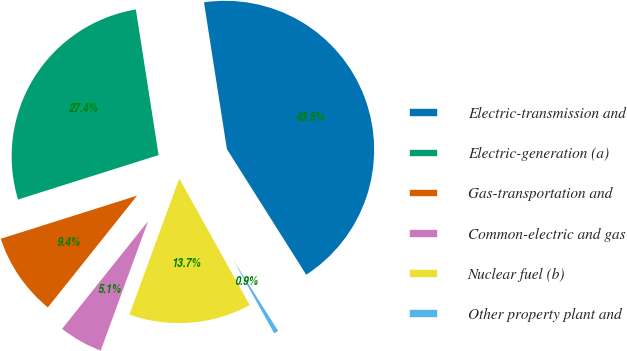<chart> <loc_0><loc_0><loc_500><loc_500><pie_chart><fcel>Electric-transmission and<fcel>Electric-generation (a)<fcel>Gas-transportation and<fcel>Common-electric and gas<fcel>Nuclear fuel (b)<fcel>Other property plant and<nl><fcel>43.5%<fcel>27.41%<fcel>9.4%<fcel>5.14%<fcel>13.67%<fcel>0.88%<nl></chart> 